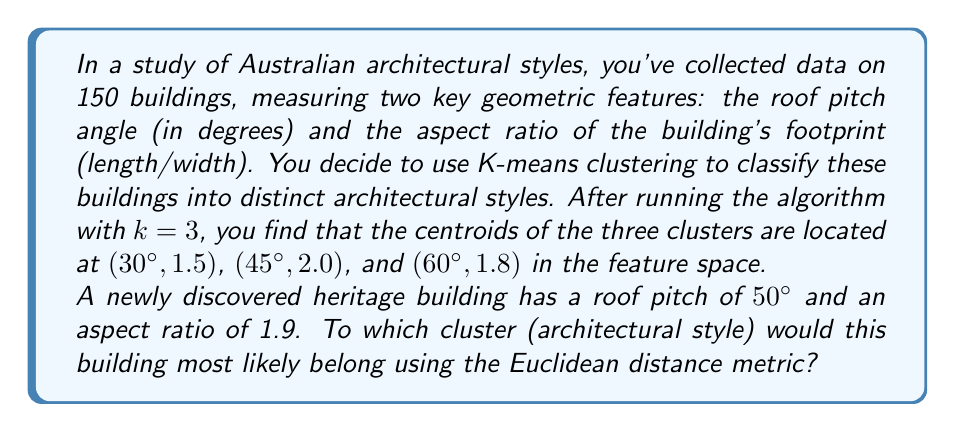Could you help me with this problem? To solve this problem, we need to calculate the Euclidean distance between the new building's features and each of the cluster centroids. The building will be assigned to the cluster with the smallest distance.

Let's define our new building's features as $(x, y) = (50, 1.9)$.

The Euclidean distance formula in 2D space is:

$$d = \sqrt{(x_2 - x_1)^2 + (y_2 - y_1)^2}$$

Where $(x_1, y_1)$ is the new building's features and $(x_2, y_2)$ is the centroid of each cluster.

Let's calculate the distance to each centroid:

1. Distance to centroid 1 (30°, 1.5):
   $$d_1 = \sqrt{(50 - 30)^2 + (1.9 - 1.5)^2} = \sqrt{400 + 0.16} = \sqrt{400.16} \approx 20.004$$

2. Distance to centroid 2 (45°, 2.0):
   $$d_2 = \sqrt{(50 - 45)^2 + (1.9 - 2.0)^2} = \sqrt{25 + 0.01} = \sqrt{25.01} = 5.001$$

3. Distance to centroid 3 (60°, 1.8):
   $$d_3 = \sqrt{(50 - 60)^2 + (1.9 - 1.8)^2} = \sqrt{100 + 0.01} = \sqrt{100.01} = 10.0005$$

The smallest distance is $d_2 = 5.001$, which corresponds to the second cluster centroid (45°, 2.0).
Answer: The newly discovered heritage building would most likely belong to the second cluster (architectural style), represented by the centroid (45°, 2.0). 